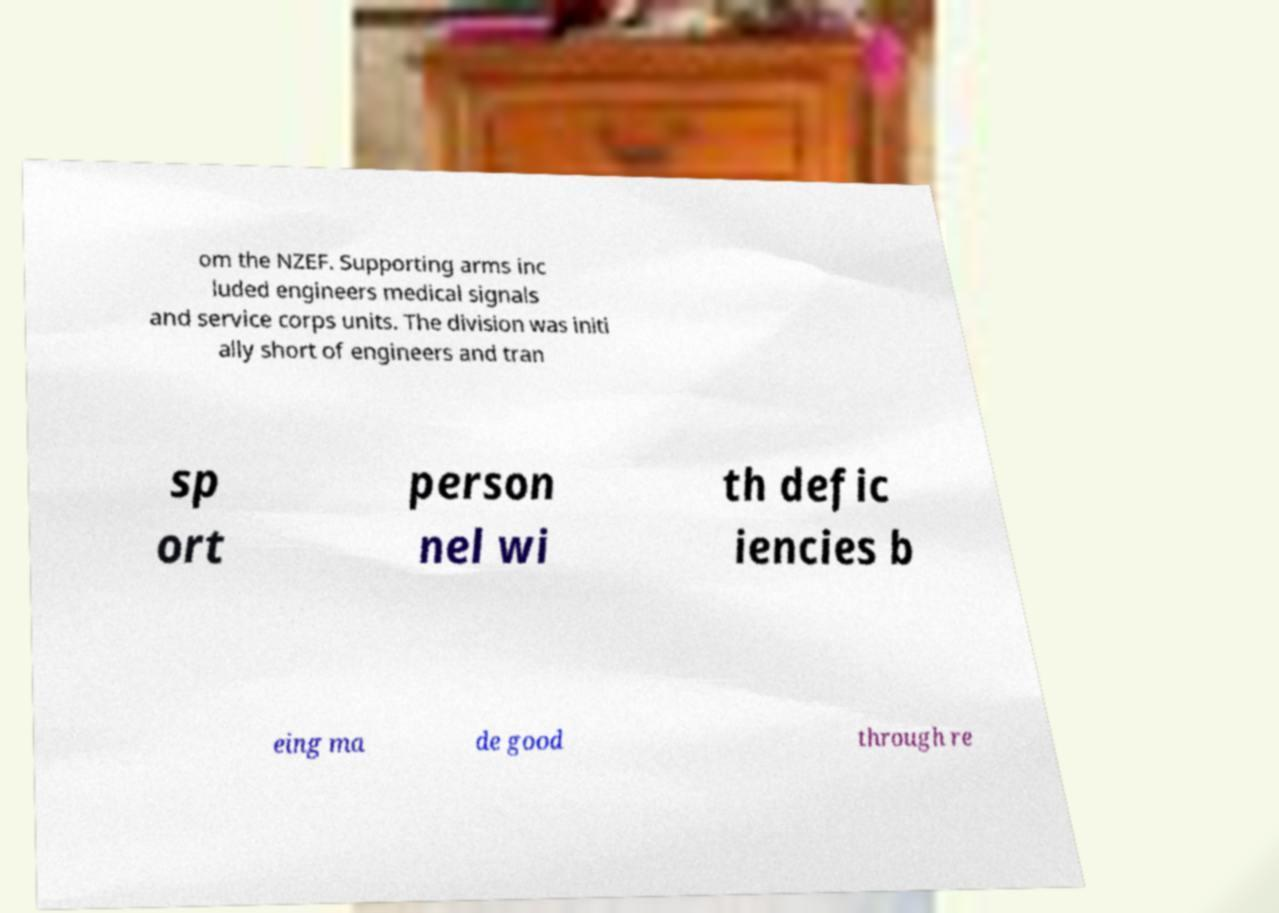For documentation purposes, I need the text within this image transcribed. Could you provide that? om the NZEF. Supporting arms inc luded engineers medical signals and service corps units. The division was initi ally short of engineers and tran sp ort person nel wi th defic iencies b eing ma de good through re 